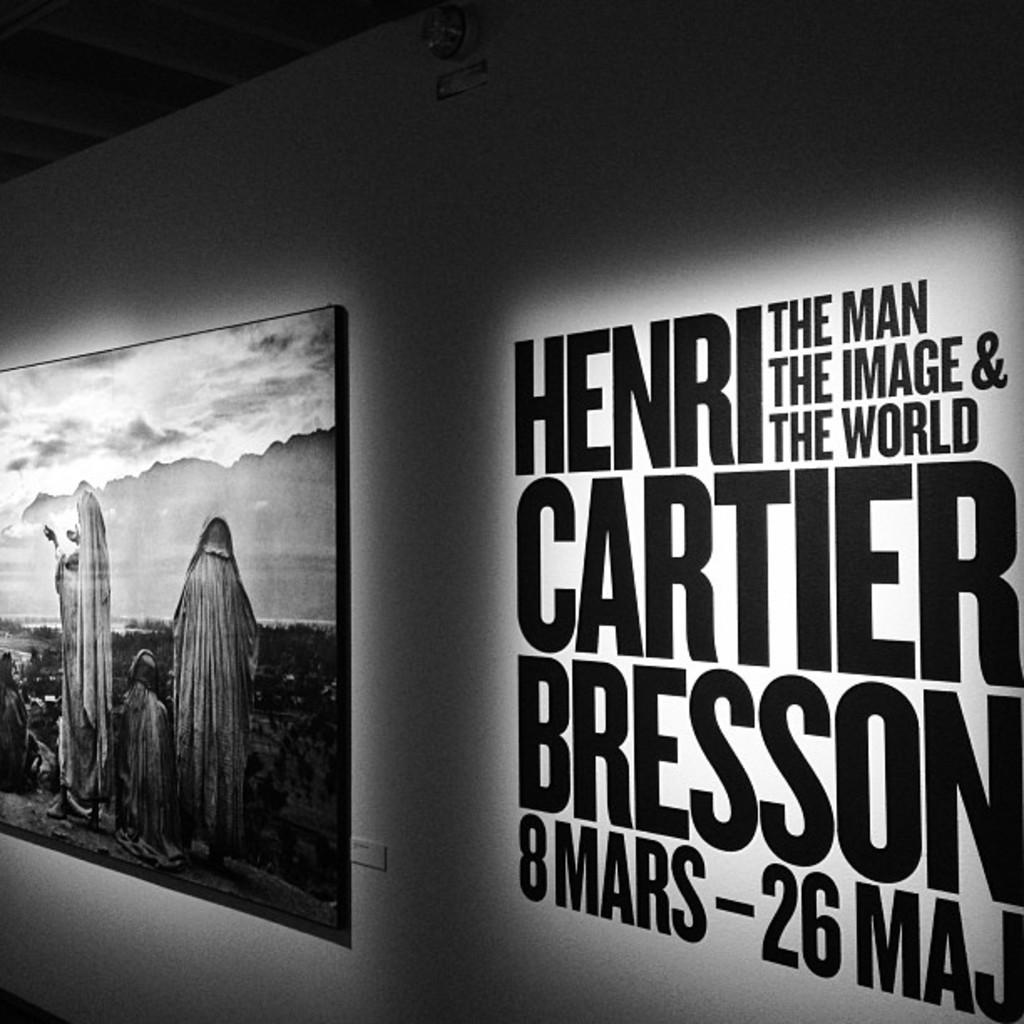<image>
Relay a brief, clear account of the picture shown. A painting is hanging next to text on a wall about Henri Cartier Bresson. 